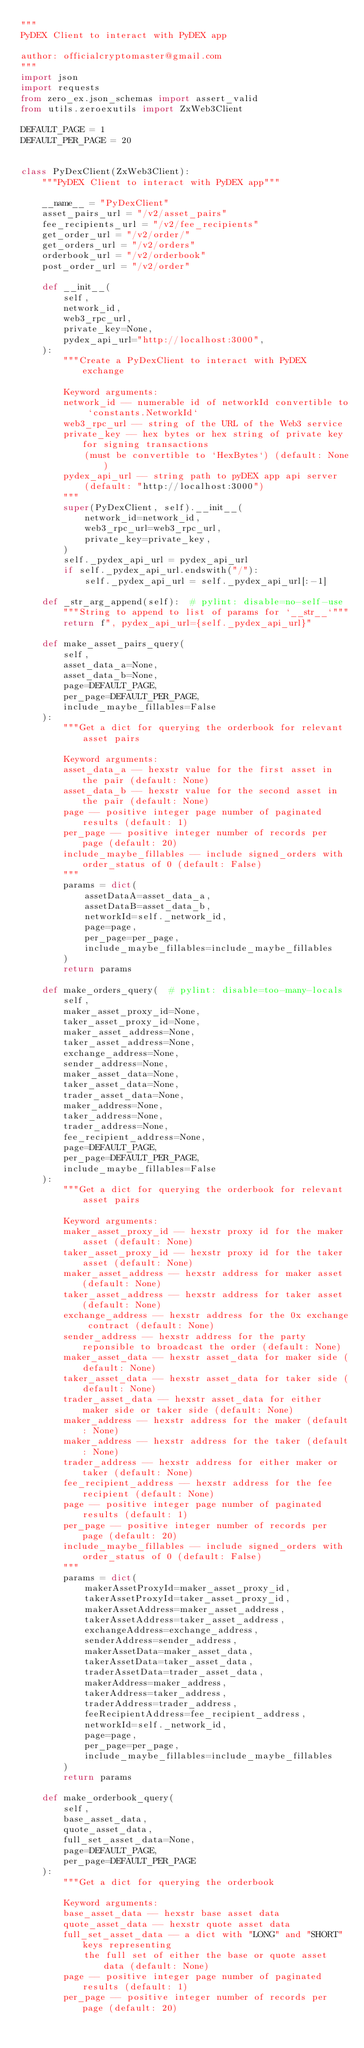Convert code to text. <code><loc_0><loc_0><loc_500><loc_500><_Python_>"""
PyDEX Client to interact with PyDEX app

author: officialcryptomaster@gmail.com
"""
import json
import requests
from zero_ex.json_schemas import assert_valid
from utils.zeroexutils import ZxWeb3Client

DEFAULT_PAGE = 1
DEFAULT_PER_PAGE = 20


class PyDexClient(ZxWeb3Client):
    """PyDEX Client to interact with PyDEX app"""

    __name__ = "PyDexClient"
    asset_pairs_url = "/v2/asset_pairs"
    fee_recipients_url = "/v2/fee_recipients"
    get_order_url = "/v2/order/"
    get_orders_url = "/v2/orders"
    orderbook_url = "/v2/orderbook"
    post_order_url = "/v2/order"

    def __init__(
        self,
        network_id,
        web3_rpc_url,
        private_key=None,
        pydex_api_url="http://localhost:3000",
    ):
        """Create a PyDexClient to interact with PyDEX exchange

        Keyword arguments:
        network_id -- numerable id of networkId convertible to `constants.NetworkId`
        web3_rpc_url -- string of the URL of the Web3 service
        private_key -- hex bytes or hex string of private key for signing transactions
            (must be convertible to `HexBytes`) (default: None)
        pydex_api_url -- string path to pyDEX app api server
            (default: "http://localhost:3000")
        """
        super(PyDexClient, self).__init__(
            network_id=network_id,
            web3_rpc_url=web3_rpc_url,
            private_key=private_key,
        )
        self._pydex_api_url = pydex_api_url
        if self._pydex_api_url.endswith("/"):
            self._pydex_api_url = self._pydex_api_url[:-1]

    def _str_arg_append(self):  # pylint: disable=no-self-use
        """String to append to list of params for `__str__`"""
        return f", pydex_api_url={self._pydex_api_url}"

    def make_asset_pairs_query(
        self,
        asset_data_a=None,
        asset_data_b=None,
        page=DEFAULT_PAGE,
        per_page=DEFAULT_PER_PAGE,
        include_maybe_fillables=False
    ):
        """Get a dict for querying the orderbook for relevant asset pairs

        Keyword arguments:
        asset_data_a -- hexstr value for the first asset in the pair (default: None)
        asset_data_b -- hexstr value for the second asset in the pair (default: None)
        page -- positive integer page number of paginated results (default: 1)
        per_page -- positive integer number of records per page (default: 20)
        include_maybe_fillables -- include signed_orders with order_status of 0 (default: False)
        """
        params = dict(
            assetDataA=asset_data_a,
            assetDataB=asset_data_b,
            networkId=self._network_id,
            page=page,
            per_page=per_page,
            include_maybe_fillables=include_maybe_fillables
        )
        return params

    def make_orders_query(  # pylint: disable=too-many-locals
        self,
        maker_asset_proxy_id=None,
        taker_asset_proxy_id=None,
        maker_asset_address=None,
        taker_asset_address=None,
        exchange_address=None,
        sender_address=None,
        maker_asset_data=None,
        taker_asset_data=None,
        trader_asset_data=None,
        maker_address=None,
        taker_address=None,
        trader_address=None,
        fee_recipient_address=None,
        page=DEFAULT_PAGE,
        per_page=DEFAULT_PER_PAGE,
        include_maybe_fillables=False
    ):
        """Get a dict for querying the orderbook for relevant asset pairs

        Keyword arguments:
        maker_asset_proxy_id -- hexstr proxy id for the maker asset (default: None)
        taker_asset_proxy_id -- hexstr proxy id for the taker asset (default: None)
        maker_asset_address -- hexstr address for maker asset (default: None)
        taker_asset_address -- hexstr address for taker asset (default: None)
        exchange_address -- hexstr address for the 0x exchange contract (default: None)
        sender_address -- hexstr address for the party reponsible to broadcast the order (default: None)
        maker_asset_data -- hexstr asset_data for maker side (default: None)
        taker_asset_data -- hexstr asset_data for taker side (default: None)
        trader_asset_data -- hexstr asset_data for either maker side or taker side (default: None)
        maker_address -- hexstr address for the maker (default: None)
        maker_address -- hexstr address for the taker (default: None)
        trader_address -- hexstr address for either maker or taker (default: None)
        fee_recipient_address -- hexstr address for the fee recipient (default: None)
        page -- positive integer page number of paginated results (default: 1)
        per_page -- positive integer number of records per page (default: 20)
        include_maybe_fillables -- include signed_orders with order_status of 0 (default: False)
        """
        params = dict(
            makerAssetProxyId=maker_asset_proxy_id,
            takerAssetProxyId=taker_asset_proxy_id,
            makerAssetAddress=maker_asset_address,
            takerAssetAddress=taker_asset_address,
            exchangeAddress=exchange_address,
            senderAddress=sender_address,
            makerAssetData=maker_asset_data,
            takerAssetData=taker_asset_data,
            traderAssetData=trader_asset_data,
            makerAddress=maker_address,
            takerAddress=taker_address,
            traderAddress=trader_address,
            feeRecipientAddress=fee_recipient_address,
            networkId=self._network_id,
            page=page,
            per_page=per_page,
            include_maybe_fillables=include_maybe_fillables
        )
        return params

    def make_orderbook_query(
        self,
        base_asset_data,
        quote_asset_data,
        full_set_asset_data=None,
        page=DEFAULT_PAGE,
        per_page=DEFAULT_PER_PAGE
    ):
        """Get a dict for querying the orderbook

        Keyword arguments:
        base_asset_data -- hexstr base asset data
        quote_asset_data -- hexstr quote asset data
        full_set_asset_data -- a dict with "LONG" and "SHORT" keys representing
            the full set of either the base or quote asset data (default: None)
        page -- positive integer page number of paginated results (default: 1)
        per_page -- positive integer number of records per page (default: 20)</code> 